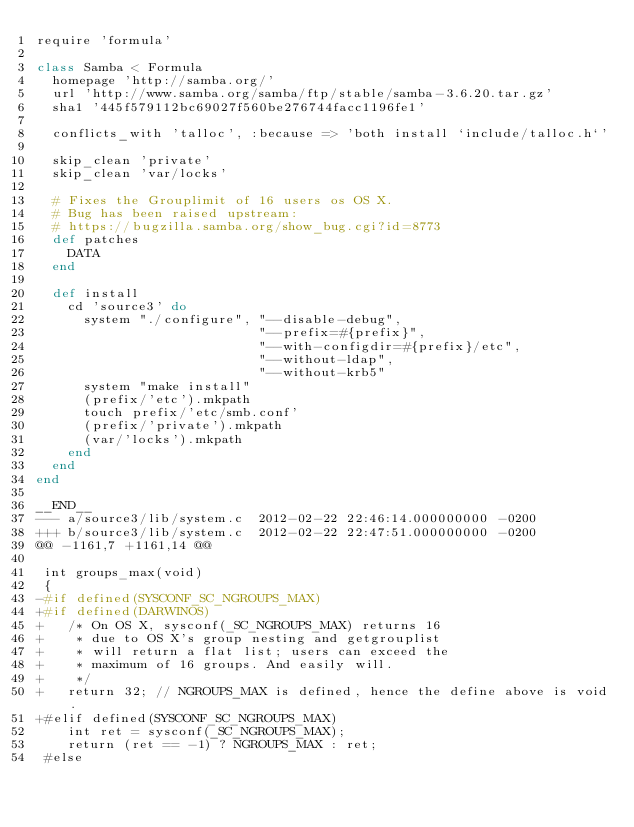Convert code to text. <code><loc_0><loc_0><loc_500><loc_500><_Ruby_>require 'formula'

class Samba < Formula
  homepage 'http://samba.org/'
  url 'http://www.samba.org/samba/ftp/stable/samba-3.6.20.tar.gz'
  sha1 '445f579112bc69027f560be276744facc1196fe1'

  conflicts_with 'talloc', :because => 'both install `include/talloc.h`'

  skip_clean 'private'
  skip_clean 'var/locks'

  # Fixes the Grouplimit of 16 users os OS X.
  # Bug has been raised upstream:
  # https://bugzilla.samba.org/show_bug.cgi?id=8773
  def patches
    DATA
  end

  def install
    cd 'source3' do
      system "./configure", "--disable-debug",
                            "--prefix=#{prefix}",
                            "--with-configdir=#{prefix}/etc",
                            "--without-ldap",
                            "--without-krb5"
      system "make install"
      (prefix/'etc').mkpath
      touch prefix/'etc/smb.conf'
      (prefix/'private').mkpath
      (var/'locks').mkpath
    end
  end
end

__END__
--- a/source3/lib/system.c	2012-02-22 22:46:14.000000000 -0200
+++ b/source3/lib/system.c	2012-02-22 22:47:51.000000000 -0200
@@ -1161,7 +1161,14 @@
 
 int groups_max(void)
 {
-#if defined(SYSCONF_SC_NGROUPS_MAX)
+#if defined(DARWINOS)
+	/* On OS X, sysconf(_SC_NGROUPS_MAX) returns 16
+	 * due to OS X's group nesting and getgrouplist
+	 * will return a flat list; users can exceed the
+	 * maximum of 16 groups. And easily will.
+	 */
+	return 32; // NGROUPS_MAX is defined, hence the define above is void.
+#elif defined(SYSCONF_SC_NGROUPS_MAX)
 	int ret = sysconf(_SC_NGROUPS_MAX);
 	return (ret == -1) ? NGROUPS_MAX : ret;
 #else
</code> 